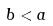<formula> <loc_0><loc_0><loc_500><loc_500>b < a</formula> 